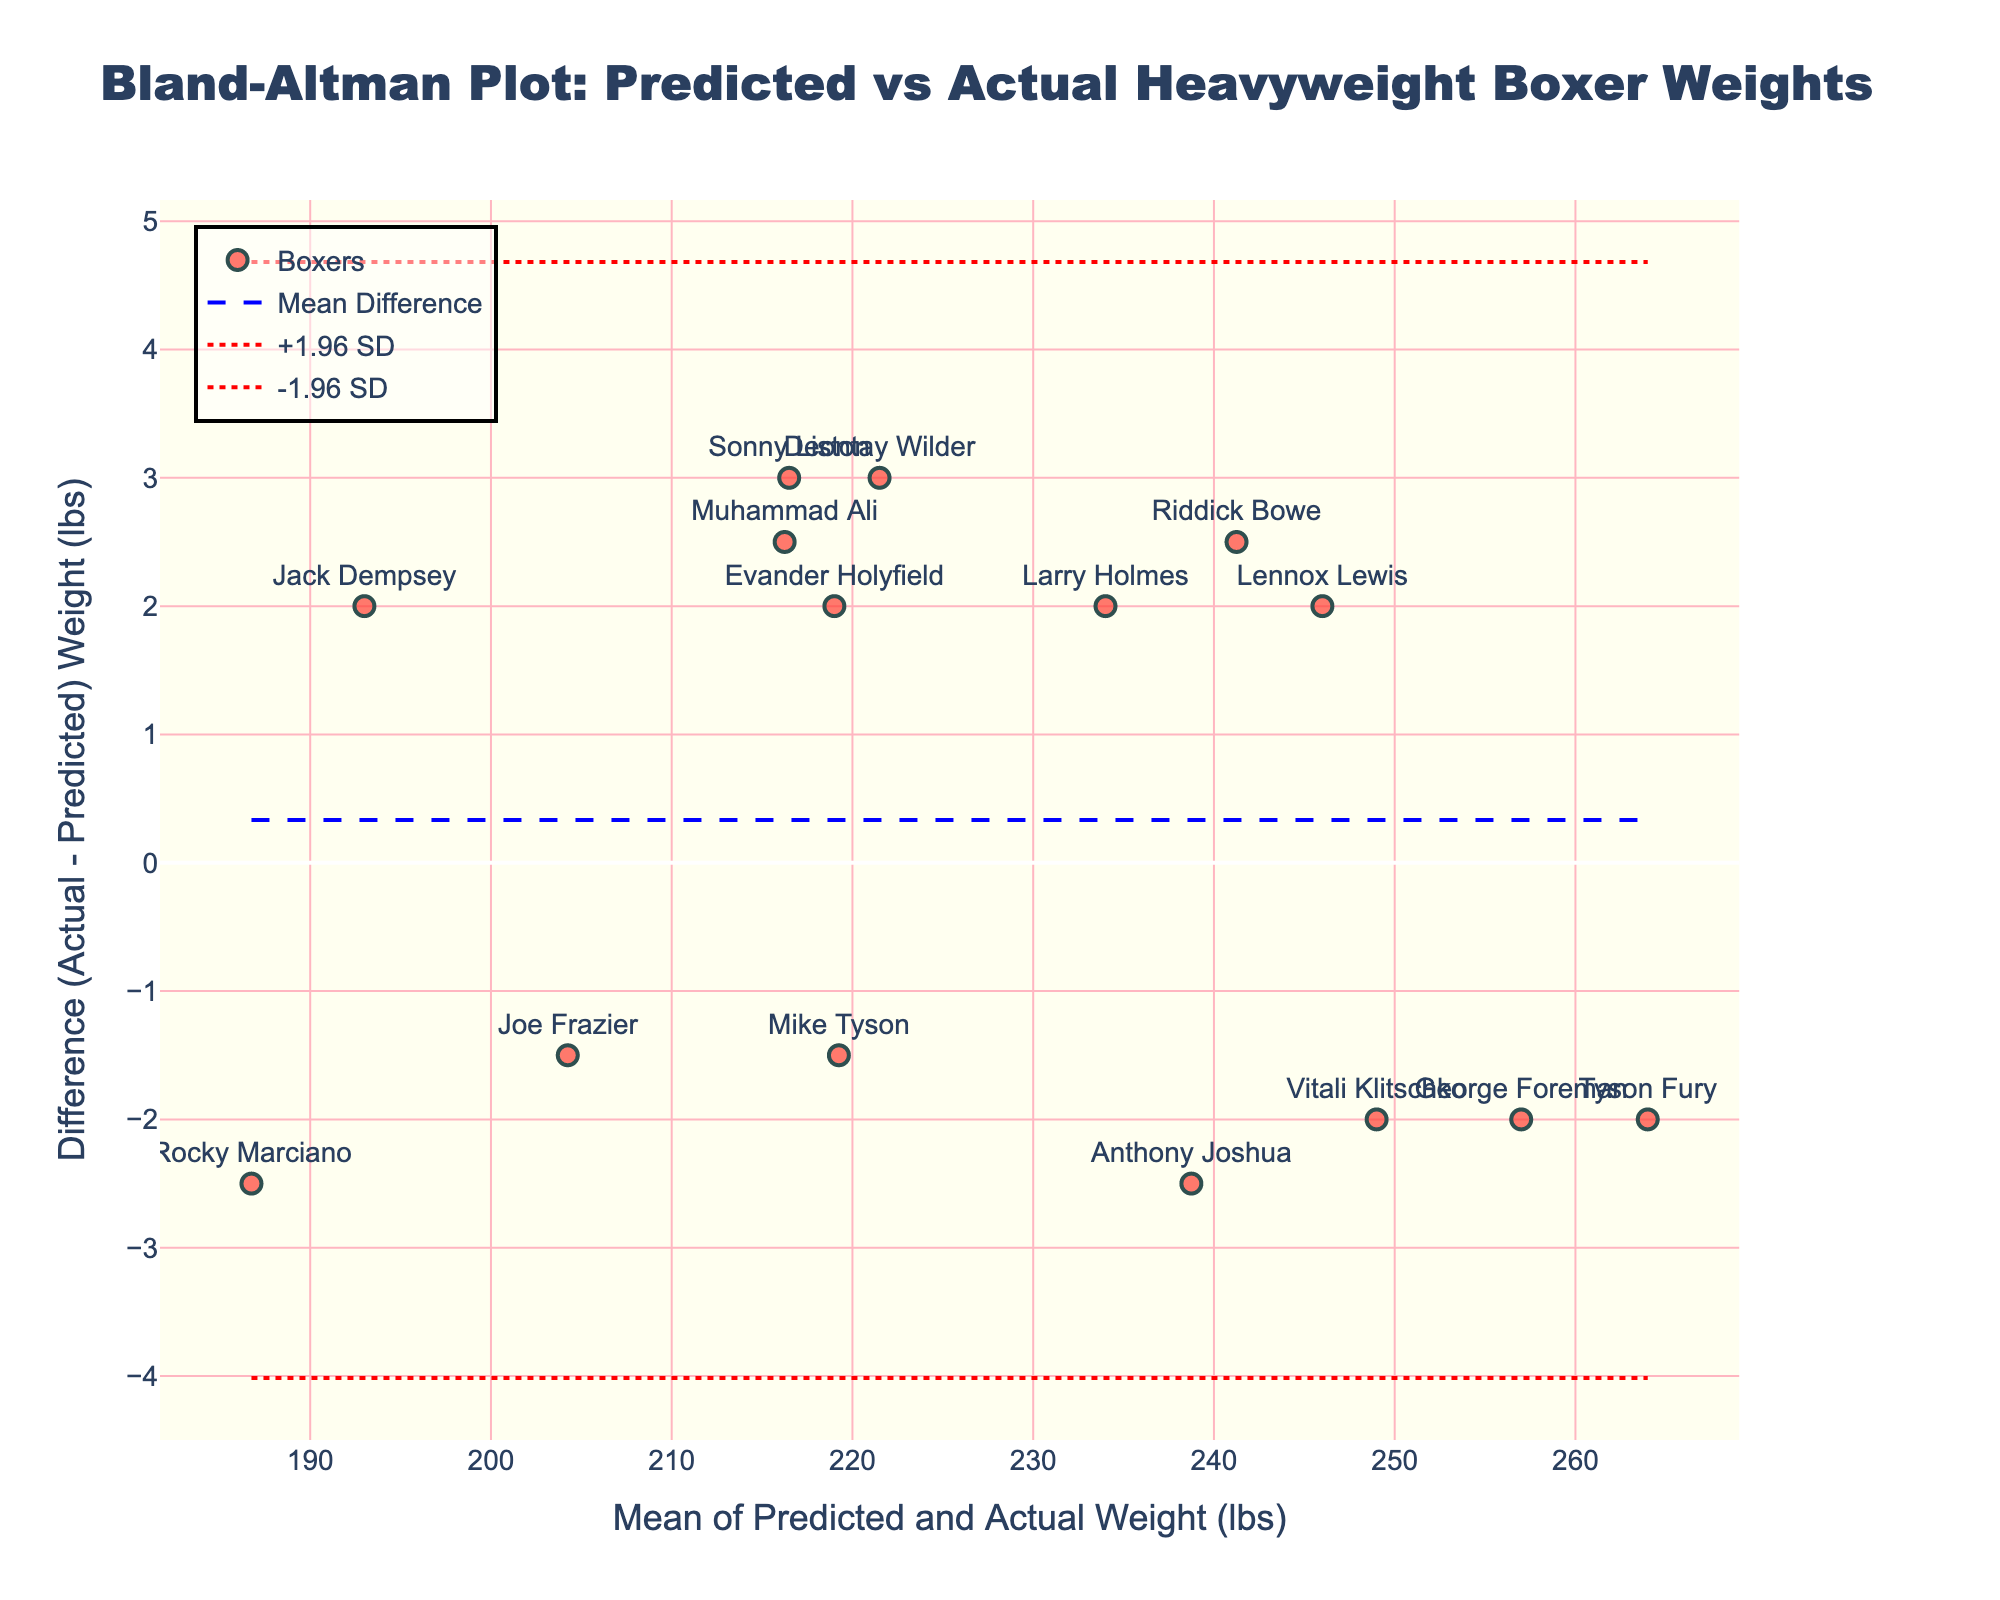What is the title of the plot? The title of the plot is at the top of the figure. It reads "Bland-Altman Plot: Predicted vs Actual Heavyweight Boxer Weights."
Answer: Bland-Altman Plot: Predicted vs Actual Heavyweight Boxer Weights How many boxers are represented in the plot? Count the number of distinct markers (points) or boxer names shown in the figure. There are 15 markers, indicating 15 different boxers.
Answer: 15 What does the x-axis represent? The x-axis represents the mean of the predicted and actual weights of the boxers. This is shown by the x-axis title "Mean of Predicted and Actual Weight (lbs)."
Answer: Mean of Predicted and Actual Weight (lbs) What is the upper limit of agreement? The upper limit of agreement is represented by the dashed red line above the mean. The y-value of this line, based on the figure's design, is labeled as "+1.96 SD."
Answer: Upper limit of agreement is the y-value of the dashed red line above the mean difference What is the mean difference in the figure? The mean difference is shown by the blue dashed line in the plot. The y-axis position of this line indicates the mean difference value.
Answer: The y-value of the blue dashed line Which boxer has the largest negative difference between predicted and actual weight? Look for the point with the greatest vertical distance below the mean difference line (the blue dashed line). The corresponding text label indicates the boxer’s name.
Answer: The boxer name at the lowest point below the blue dashed line What is the approximate difference for Evander Holyfield? Find the data point labeled "Evander Holyfield," which is near the origin, and check its vertical position relative to the difference axis (y-axis).
Answer: Around 2 lbs (actual weight is higher) Is there a trend in differences regarding heavier or lighter boxers? Observe if the plotted difference tends to increase or decrease as the mean weight increases along the x-axis. Look at the slope of the points distribution.
Answer: There seems to be no clear trend; differences appear scattered Who has the smallest difference, positive or negative, between predicted and actual weights? Locate the data point closest to the mean difference line (blue dashed line) with a nearly zero difference. Identify the corresponding boxer name.
Answer: Lennox Lewis 